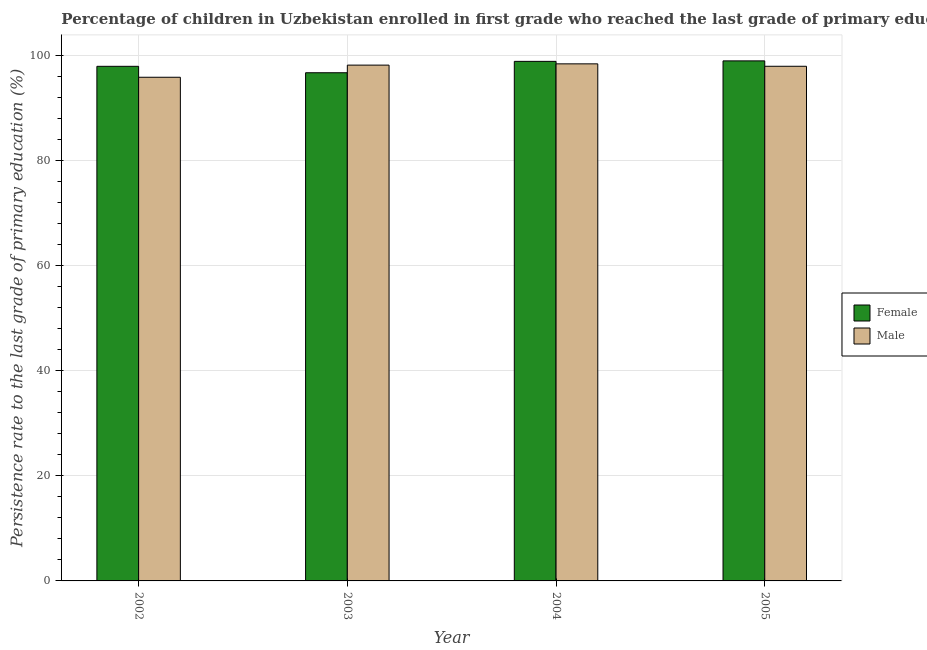How many bars are there on the 3rd tick from the left?
Provide a short and direct response. 2. How many bars are there on the 3rd tick from the right?
Your answer should be compact. 2. What is the label of the 2nd group of bars from the left?
Offer a very short reply. 2003. In how many cases, is the number of bars for a given year not equal to the number of legend labels?
Provide a short and direct response. 0. What is the persistence rate of male students in 2003?
Your response must be concise. 98.15. Across all years, what is the maximum persistence rate of male students?
Give a very brief answer. 98.39. Across all years, what is the minimum persistence rate of male students?
Make the answer very short. 95.84. What is the total persistence rate of female students in the graph?
Ensure brevity in your answer.  392.43. What is the difference between the persistence rate of male students in 2002 and that in 2003?
Ensure brevity in your answer.  -2.31. What is the difference between the persistence rate of male students in 2005 and the persistence rate of female students in 2004?
Offer a very short reply. -0.46. What is the average persistence rate of male students per year?
Your answer should be very brief. 97.57. In the year 2002, what is the difference between the persistence rate of male students and persistence rate of female students?
Your answer should be compact. 0. In how many years, is the persistence rate of male students greater than 72 %?
Provide a succinct answer. 4. What is the ratio of the persistence rate of male students in 2004 to that in 2005?
Your answer should be very brief. 1. Is the persistence rate of male students in 2003 less than that in 2005?
Keep it short and to the point. No. What is the difference between the highest and the second highest persistence rate of female students?
Keep it short and to the point. 0.09. What is the difference between the highest and the lowest persistence rate of male students?
Offer a very short reply. 2.55. Are all the bars in the graph horizontal?
Provide a short and direct response. No. Are the values on the major ticks of Y-axis written in scientific E-notation?
Make the answer very short. No. Does the graph contain any zero values?
Provide a short and direct response. No. How many legend labels are there?
Ensure brevity in your answer.  2. How are the legend labels stacked?
Offer a terse response. Vertical. What is the title of the graph?
Provide a short and direct response. Percentage of children in Uzbekistan enrolled in first grade who reached the last grade of primary education. Does "Lowest 10% of population" appear as one of the legend labels in the graph?
Ensure brevity in your answer.  No. What is the label or title of the X-axis?
Ensure brevity in your answer.  Year. What is the label or title of the Y-axis?
Offer a very short reply. Persistence rate to the last grade of primary education (%). What is the Persistence rate to the last grade of primary education (%) of Female in 2002?
Give a very brief answer. 97.92. What is the Persistence rate to the last grade of primary education (%) in Male in 2002?
Provide a short and direct response. 95.84. What is the Persistence rate to the last grade of primary education (%) in Female in 2003?
Keep it short and to the point. 96.69. What is the Persistence rate to the last grade of primary education (%) in Male in 2003?
Your answer should be very brief. 98.15. What is the Persistence rate to the last grade of primary education (%) of Female in 2004?
Provide a succinct answer. 98.86. What is the Persistence rate to the last grade of primary education (%) of Male in 2004?
Offer a very short reply. 98.39. What is the Persistence rate to the last grade of primary education (%) of Female in 2005?
Make the answer very short. 98.95. What is the Persistence rate to the last grade of primary education (%) of Male in 2005?
Provide a succinct answer. 97.93. Across all years, what is the maximum Persistence rate to the last grade of primary education (%) in Female?
Your answer should be very brief. 98.95. Across all years, what is the maximum Persistence rate to the last grade of primary education (%) of Male?
Provide a succinct answer. 98.39. Across all years, what is the minimum Persistence rate to the last grade of primary education (%) of Female?
Your answer should be compact. 96.69. Across all years, what is the minimum Persistence rate to the last grade of primary education (%) in Male?
Offer a very short reply. 95.84. What is the total Persistence rate to the last grade of primary education (%) of Female in the graph?
Keep it short and to the point. 392.43. What is the total Persistence rate to the last grade of primary education (%) in Male in the graph?
Ensure brevity in your answer.  390.3. What is the difference between the Persistence rate to the last grade of primary education (%) of Female in 2002 and that in 2003?
Ensure brevity in your answer.  1.22. What is the difference between the Persistence rate to the last grade of primary education (%) in Male in 2002 and that in 2003?
Ensure brevity in your answer.  -2.31. What is the difference between the Persistence rate to the last grade of primary education (%) in Female in 2002 and that in 2004?
Ensure brevity in your answer.  -0.94. What is the difference between the Persistence rate to the last grade of primary education (%) of Male in 2002 and that in 2004?
Your answer should be very brief. -2.55. What is the difference between the Persistence rate to the last grade of primary education (%) of Female in 2002 and that in 2005?
Provide a short and direct response. -1.04. What is the difference between the Persistence rate to the last grade of primary education (%) in Male in 2002 and that in 2005?
Provide a succinct answer. -2.09. What is the difference between the Persistence rate to the last grade of primary education (%) in Female in 2003 and that in 2004?
Ensure brevity in your answer.  -2.17. What is the difference between the Persistence rate to the last grade of primary education (%) of Male in 2003 and that in 2004?
Give a very brief answer. -0.24. What is the difference between the Persistence rate to the last grade of primary education (%) in Female in 2003 and that in 2005?
Give a very brief answer. -2.26. What is the difference between the Persistence rate to the last grade of primary education (%) of Male in 2003 and that in 2005?
Ensure brevity in your answer.  0.22. What is the difference between the Persistence rate to the last grade of primary education (%) in Female in 2004 and that in 2005?
Provide a succinct answer. -0.09. What is the difference between the Persistence rate to the last grade of primary education (%) in Male in 2004 and that in 2005?
Your answer should be compact. 0.46. What is the difference between the Persistence rate to the last grade of primary education (%) in Female in 2002 and the Persistence rate to the last grade of primary education (%) in Male in 2003?
Your response must be concise. -0.23. What is the difference between the Persistence rate to the last grade of primary education (%) of Female in 2002 and the Persistence rate to the last grade of primary education (%) of Male in 2004?
Give a very brief answer. -0.47. What is the difference between the Persistence rate to the last grade of primary education (%) of Female in 2002 and the Persistence rate to the last grade of primary education (%) of Male in 2005?
Provide a short and direct response. -0.01. What is the difference between the Persistence rate to the last grade of primary education (%) of Female in 2003 and the Persistence rate to the last grade of primary education (%) of Male in 2004?
Give a very brief answer. -1.69. What is the difference between the Persistence rate to the last grade of primary education (%) in Female in 2003 and the Persistence rate to the last grade of primary education (%) in Male in 2005?
Provide a succinct answer. -1.23. What is the difference between the Persistence rate to the last grade of primary education (%) of Female in 2004 and the Persistence rate to the last grade of primary education (%) of Male in 2005?
Ensure brevity in your answer.  0.93. What is the average Persistence rate to the last grade of primary education (%) of Female per year?
Your answer should be compact. 98.11. What is the average Persistence rate to the last grade of primary education (%) of Male per year?
Provide a succinct answer. 97.57. In the year 2002, what is the difference between the Persistence rate to the last grade of primary education (%) in Female and Persistence rate to the last grade of primary education (%) in Male?
Make the answer very short. 2.08. In the year 2003, what is the difference between the Persistence rate to the last grade of primary education (%) of Female and Persistence rate to the last grade of primary education (%) of Male?
Offer a very short reply. -1.45. In the year 2004, what is the difference between the Persistence rate to the last grade of primary education (%) in Female and Persistence rate to the last grade of primary education (%) in Male?
Provide a succinct answer. 0.47. In the year 2005, what is the difference between the Persistence rate to the last grade of primary education (%) in Female and Persistence rate to the last grade of primary education (%) in Male?
Your response must be concise. 1.03. What is the ratio of the Persistence rate to the last grade of primary education (%) in Female in 2002 to that in 2003?
Your response must be concise. 1.01. What is the ratio of the Persistence rate to the last grade of primary education (%) of Male in 2002 to that in 2003?
Offer a terse response. 0.98. What is the ratio of the Persistence rate to the last grade of primary education (%) of Male in 2002 to that in 2004?
Make the answer very short. 0.97. What is the ratio of the Persistence rate to the last grade of primary education (%) of Female in 2002 to that in 2005?
Your response must be concise. 0.99. What is the ratio of the Persistence rate to the last grade of primary education (%) of Male in 2002 to that in 2005?
Ensure brevity in your answer.  0.98. What is the ratio of the Persistence rate to the last grade of primary education (%) of Female in 2003 to that in 2004?
Your answer should be very brief. 0.98. What is the ratio of the Persistence rate to the last grade of primary education (%) of Male in 2003 to that in 2004?
Give a very brief answer. 1. What is the ratio of the Persistence rate to the last grade of primary education (%) of Female in 2003 to that in 2005?
Ensure brevity in your answer.  0.98. What is the ratio of the Persistence rate to the last grade of primary education (%) of Male in 2003 to that in 2005?
Make the answer very short. 1. What is the ratio of the Persistence rate to the last grade of primary education (%) of Female in 2004 to that in 2005?
Give a very brief answer. 1. What is the ratio of the Persistence rate to the last grade of primary education (%) of Male in 2004 to that in 2005?
Keep it short and to the point. 1. What is the difference between the highest and the second highest Persistence rate to the last grade of primary education (%) of Female?
Make the answer very short. 0.09. What is the difference between the highest and the second highest Persistence rate to the last grade of primary education (%) of Male?
Provide a short and direct response. 0.24. What is the difference between the highest and the lowest Persistence rate to the last grade of primary education (%) in Female?
Offer a very short reply. 2.26. What is the difference between the highest and the lowest Persistence rate to the last grade of primary education (%) of Male?
Provide a short and direct response. 2.55. 